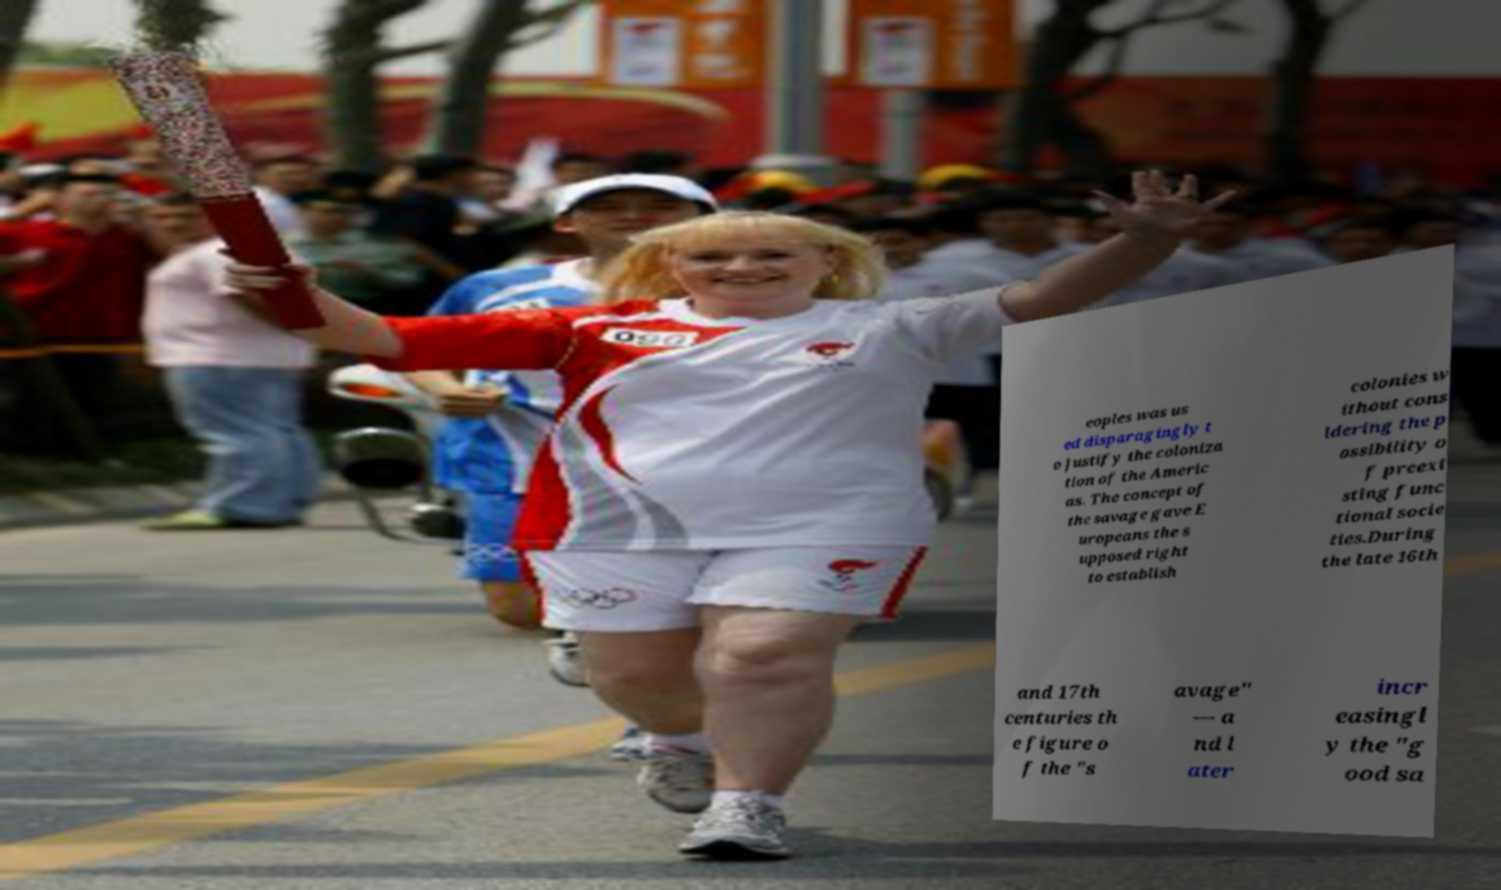Please identify and transcribe the text found in this image. eoples was us ed disparagingly t o justify the coloniza tion of the Americ as. The concept of the savage gave E uropeans the s upposed right to establish colonies w ithout cons idering the p ossibility o f preexi sting func tional socie ties.During the late 16th and 17th centuries th e figure o f the "s avage" — a nd l ater incr easingl y the "g ood sa 